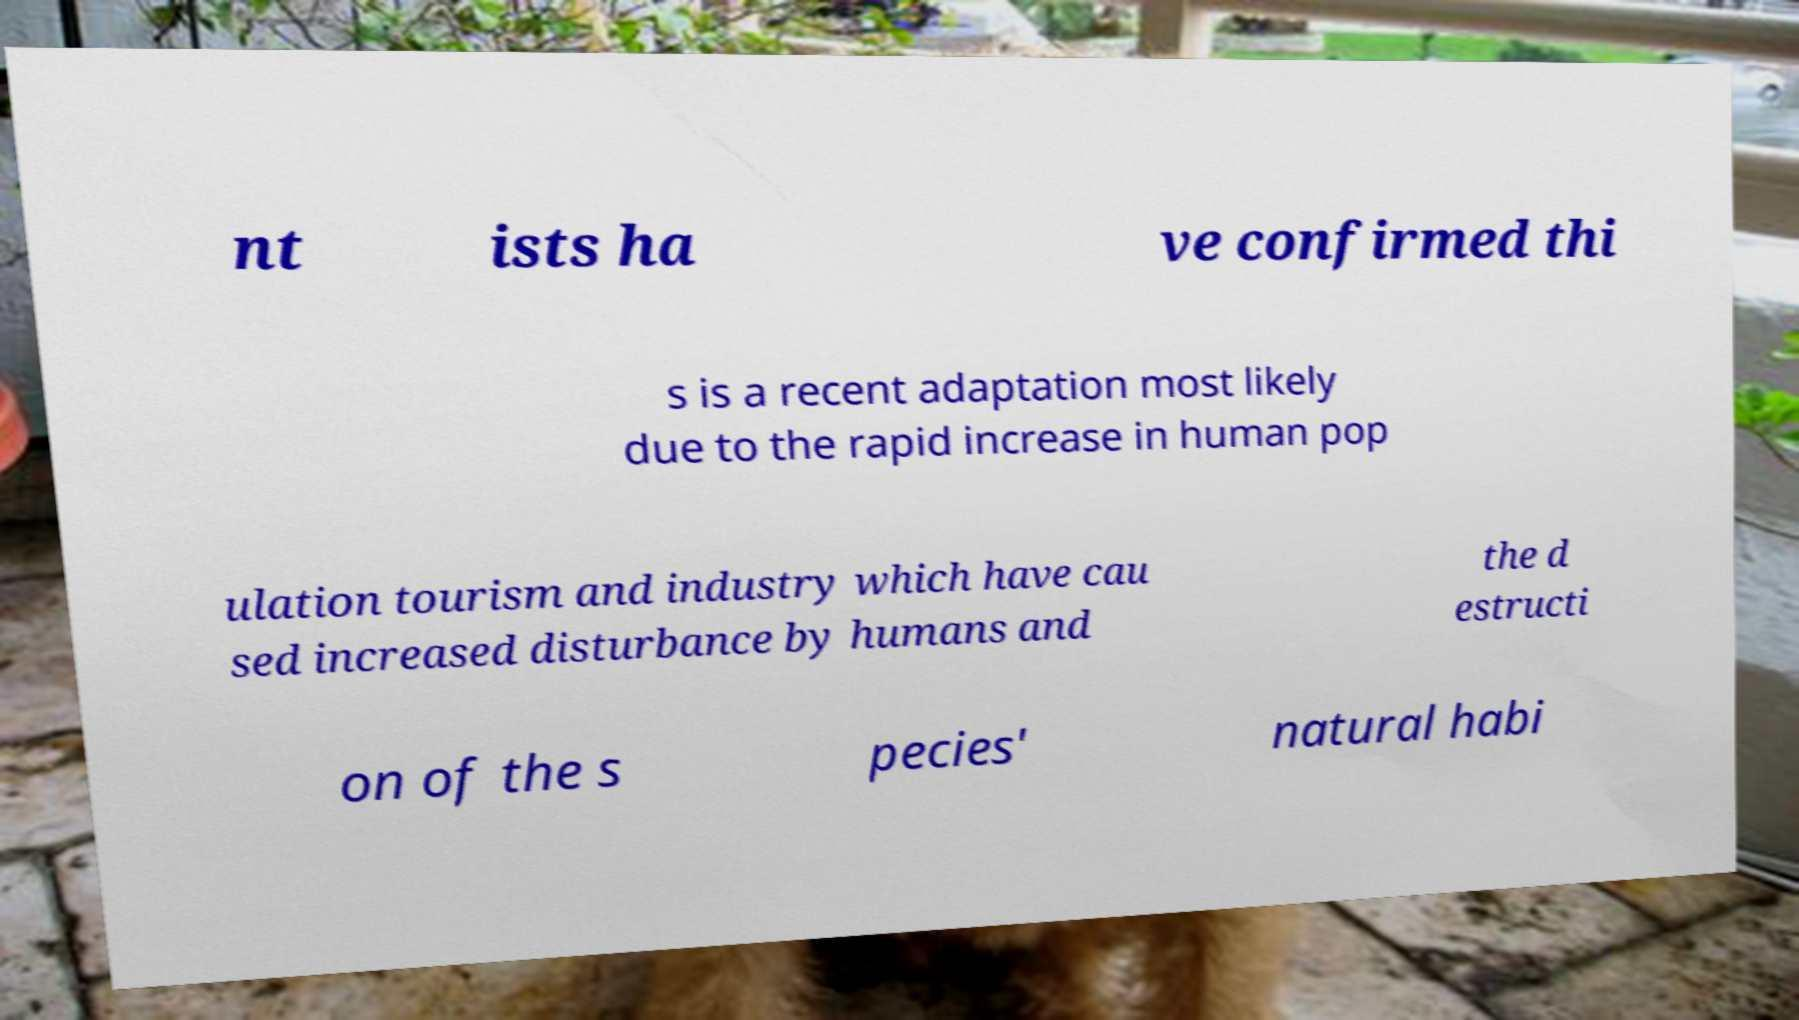For documentation purposes, I need the text within this image transcribed. Could you provide that? nt ists ha ve confirmed thi s is a recent adaptation most likely due to the rapid increase in human pop ulation tourism and industry which have cau sed increased disturbance by humans and the d estructi on of the s pecies' natural habi 